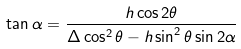Convert formula to latex. <formula><loc_0><loc_0><loc_500><loc_500>\tan \alpha = \frac { h \cos 2 \theta } { \Delta \cos ^ { 2 } \theta - h \sin ^ { 2 } \theta \sin 2 \alpha }</formula> 